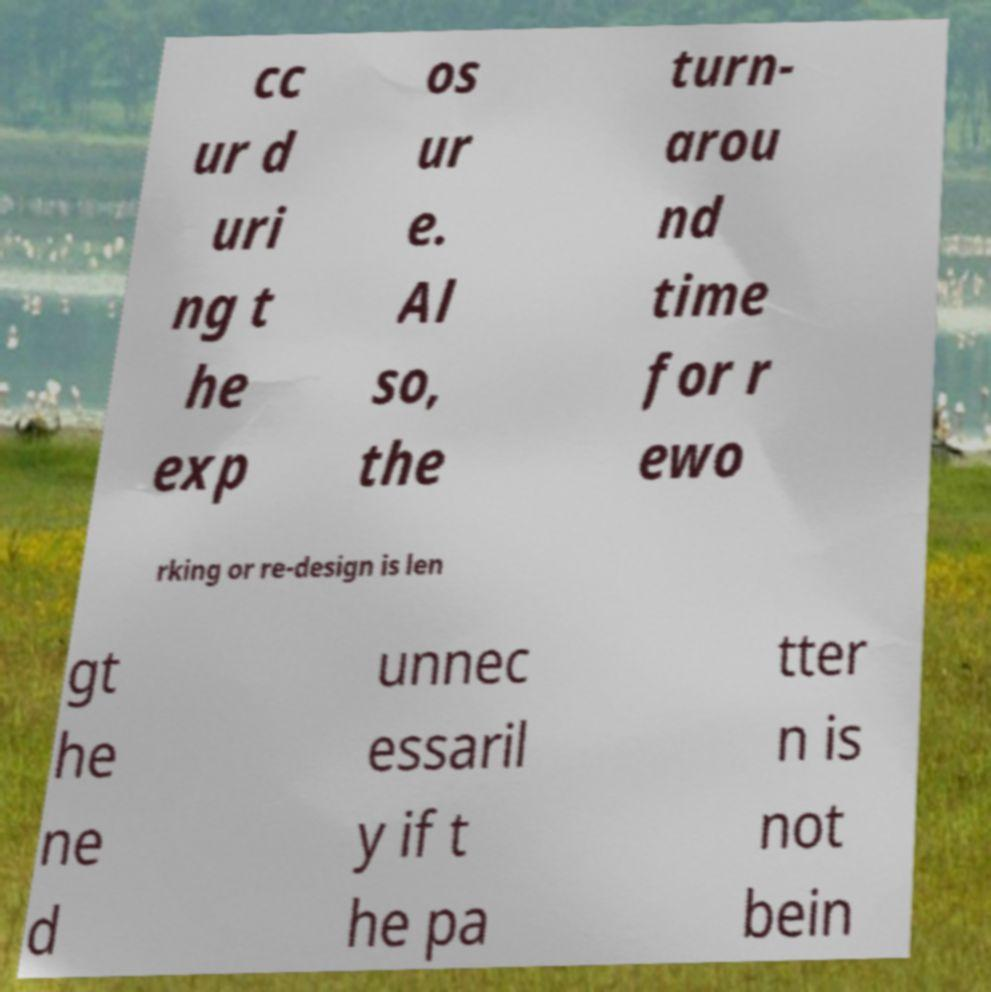There's text embedded in this image that I need extracted. Can you transcribe it verbatim? cc ur d uri ng t he exp os ur e. Al so, the turn- arou nd time for r ewo rking or re-design is len gt he ne d unnec essaril y if t he pa tter n is not bein 